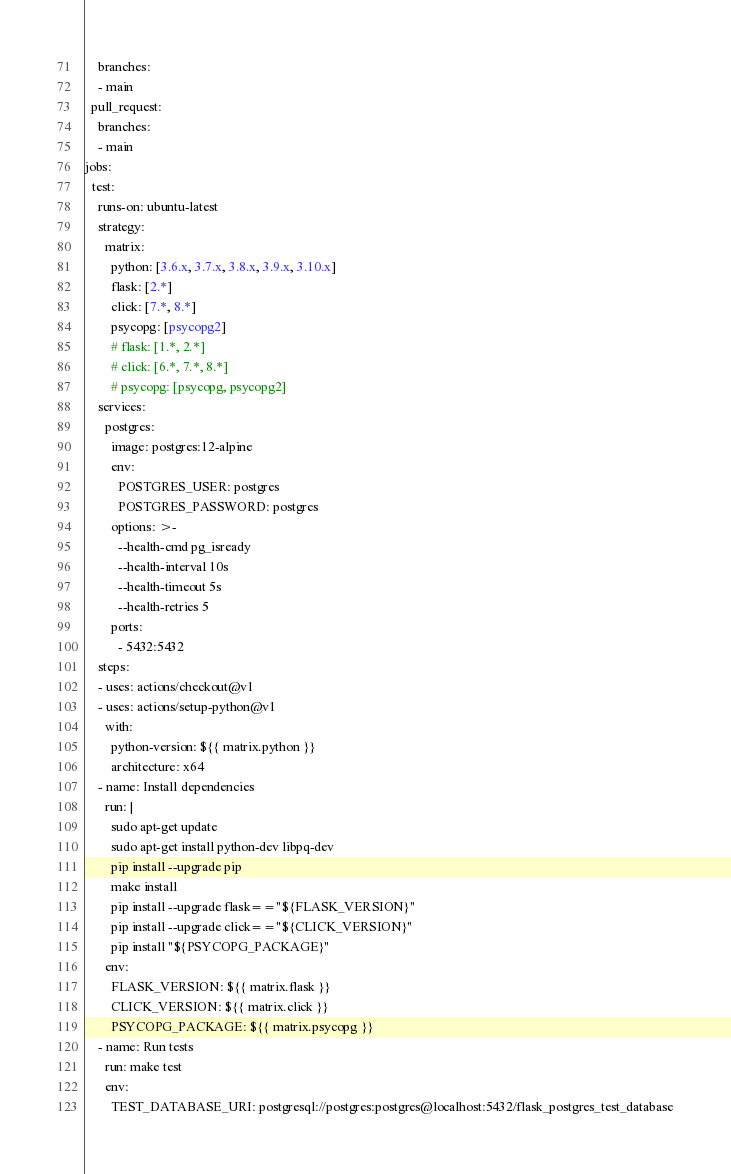<code> <loc_0><loc_0><loc_500><loc_500><_YAML_>    branches:
    - main
  pull_request:
    branches:
    - main
jobs:
  test:
    runs-on: ubuntu-latest
    strategy:
      matrix:
        python: [3.6.x, 3.7.x, 3.8.x, 3.9.x, 3.10.x]
        flask: [2.*]
        click: [7.*, 8.*]
        psycopg: [psycopg2]
        # flask: [1.*, 2.*]
        # click: [6.*, 7.*, 8.*]
        # psycopg: [psycopg, psycopg2]
    services:
      postgres:
        image: postgres:12-alpine
        env:
          POSTGRES_USER: postgres
          POSTGRES_PASSWORD: postgres
        options: >-
          --health-cmd pg_isready
          --health-interval 10s
          --health-timeout 5s
          --health-retries 5
        ports:
          - 5432:5432
    steps:
    - uses: actions/checkout@v1
    - uses: actions/setup-python@v1
      with:
        python-version: ${{ matrix.python }}
        architecture: x64
    - name: Install dependencies
      run: |
        sudo apt-get update
        sudo apt-get install python-dev libpq-dev
        pip install --upgrade pip
        make install
        pip install --upgrade flask=="${FLASK_VERSION}"
        pip install --upgrade click=="${CLICK_VERSION}"
        pip install "${PSYCOPG_PACKAGE}"
      env:
        FLASK_VERSION: ${{ matrix.flask }}
        CLICK_VERSION: ${{ matrix.click }}
        PSYCOPG_PACKAGE: ${{ matrix.psycopg }}
    - name: Run tests
      run: make test
      env:
        TEST_DATABASE_URI: postgresql://postgres:postgres@localhost:5432/flask_postgres_test_database
</code> 